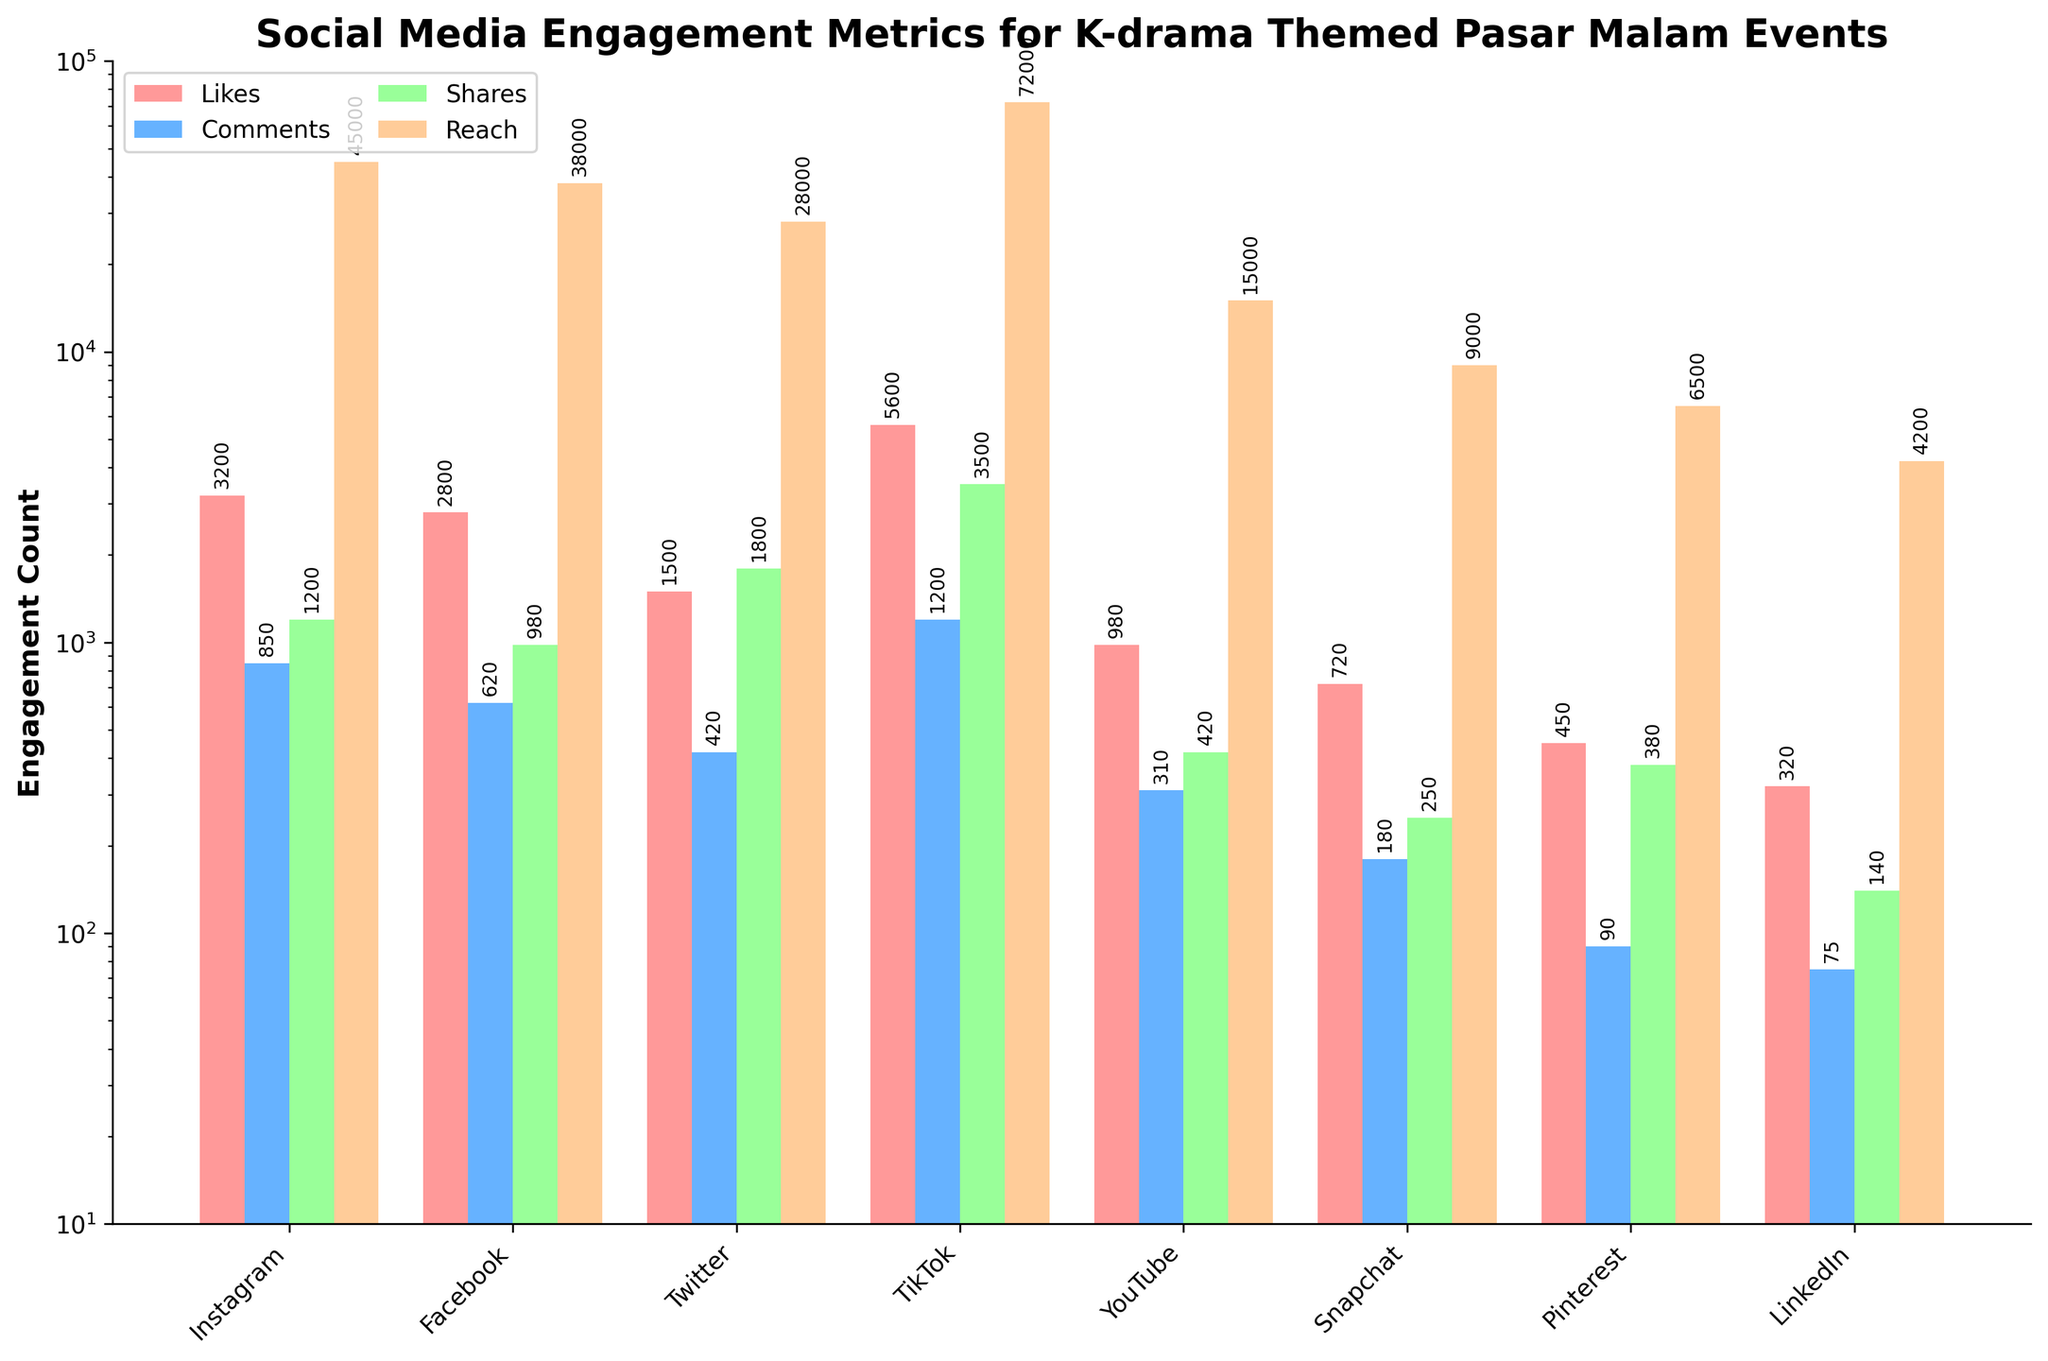Which platform has the highest number of likes? Looking at the 'Likes' bars, the tallest bar represents Instagram, Facebook, Twitter, TikTok, YouTube, Snapchat, Pinterest, and LinkedIn. The highest bar belongs to TikTok.
Answer: TikTok Which platform has the least reach? Referring to the 'Reach' metric and identifying the smallest bar, we compare Instagram, Facebook, Twitter, TikTok, YouTube, Snapchat, Pinterest, and LinkedIn. The smallest bar is for LinkedIn.
Answer: LinkedIn What is the total number of comments across all platforms? We sum the values in the 'Comments' column: 850 (Instagram) + 620 (Facebook) + 420 (Twitter) + 1200 (TikTok) + 310 (YouTube) + 180 (Snapchat) + 90 (Pinterest) + 75 (LinkedIn) = 3745
Answer: 3745 Which platform received more shares: Facebook or YouTube? Comparing the 'Shares' bars for Facebook and YouTube, Facebook has 980 shares and YouTube has 420 shares.
Answer: Facebook What is the difference in reach between TikTok and Twitter? The reach for TikTok is 72000, and for Twitter it's 28000. Subtracting these gives 72000 - 28000 = 44000.
Answer: 44000 Which platform had the highest number of shares? Observing the 'Shares' bars, the tallest one is compared among all platforms. TikTok's bar is the tallest.
Answer: TikTok How does the number of likes on Facebook compare to Instagram? Comparing the 'Likes' bars for Facebook and Instagram, Facebook has 2800 likes and Instagram has 3200 likes. Instagram has more likes.
Answer: Instagram What is the average reach across all platforms? Calculate the average by summing all 'Reach' values and dividing by the number of platforms: (45000 + 38000 + 28000 + 72000 + 15000 + 9000 + 6500 + 4200) / 8 = 218700 / 8 = 27337.5
Answer: 27337.5 Which platform had more comments: Twitter or Snapchat? Comparing the 'Comments' bars for Twitter and Snapchat, Twitter has 420 comments and Snapchat has 180 comments.
Answer: Twitter What is the sum of likes and shares for TikTok? Sum the values for 'Likes' and 'Shares' for TikTok: 5600 (Likes) + 3500 (Shares) = 9100
Answer: 9100 